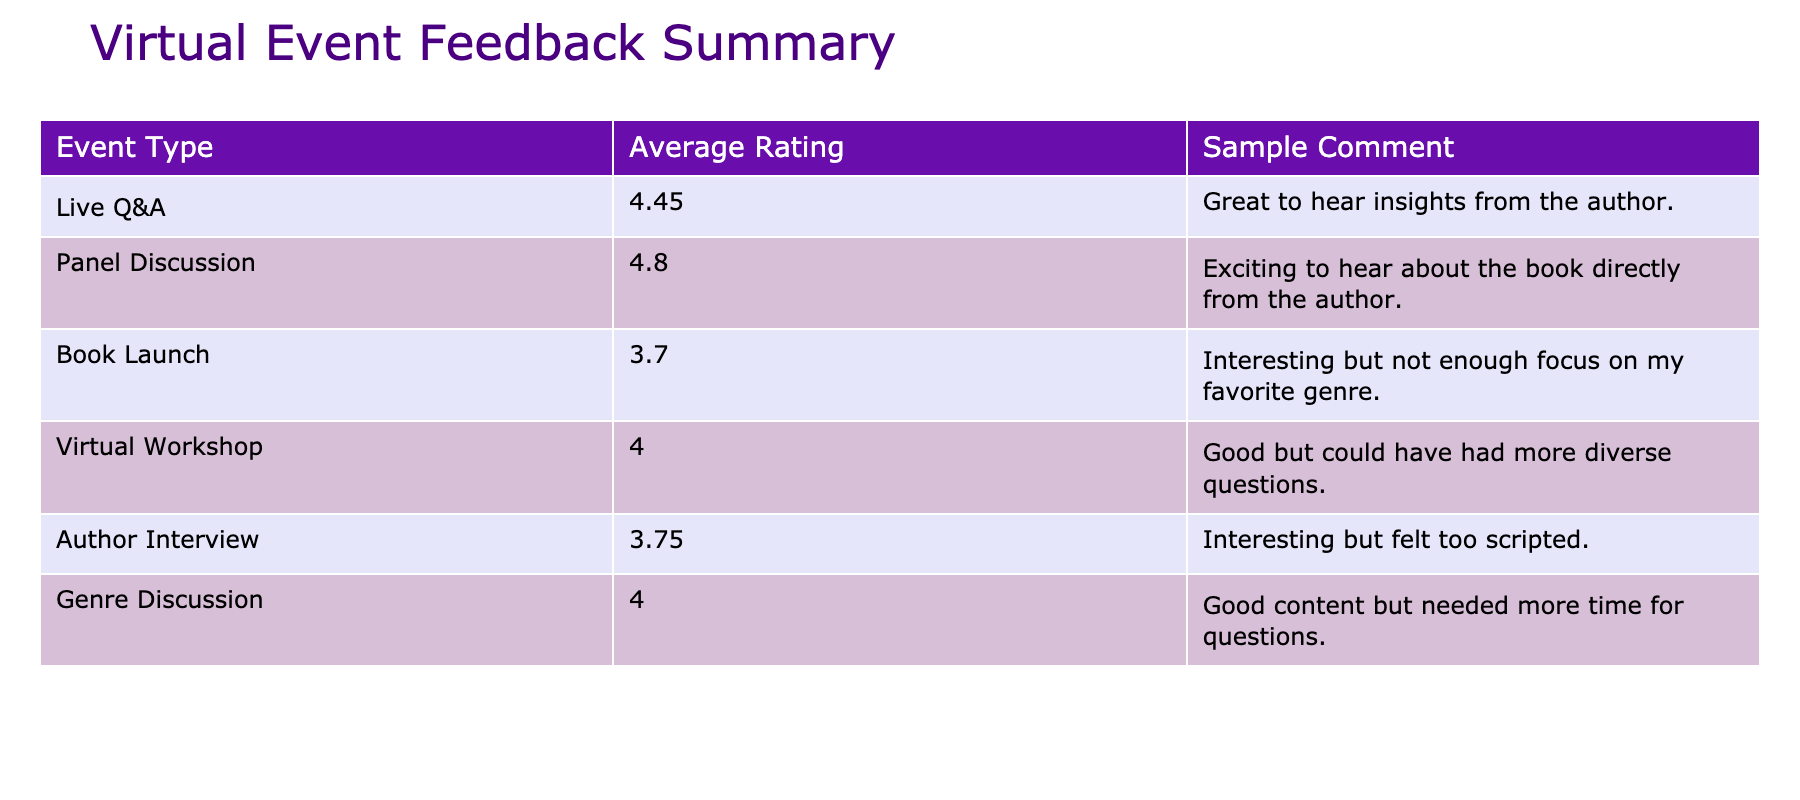What's the average feedback rating for the Author Interview event type? The Author Interview event has two feedback ratings (4.0 and 4.9). To find the average, we add them up: 4.0 + 4.9 = 8.9, then divide by 2, which equals 4.45.
Answer: 4.45 Which event type received the highest average rating? The average ratings are: Live Q&A (4.0), Panel Discussion (3.75), Book Launch (4.8), Virtual Workshop (4.0), Author Interview (4.45), and Genre Discussion (3.7). The highest is the Book Launch with 4.8.
Answer: Book Launch Is there any event type that has a feedback rating below 4.0? The Panel Discussion (3.75) and Genre Discussion (3.7) have ratings below 4.0, confirming that at least two event types fall below this threshold.
Answer: Yes What is the difference in average ratings between the highest and lowest event types? The highest average rating is 4.8 (Book Launch) and the lowest is 3.7 (Genre Discussion). The difference is 4.8 - 3.7 = 1.1.
Answer: 1.1 Did the Virtual Workshop receive mostly positive feedback? The average feedback rating for the Virtual Workshop is 4.0, which is considered a positive rating, confirming that it did receive positive feedback overall.
Answer: Yes What is the average feedback rating across all event types? The average ratings for all events are: Live Q&A (4.0), Panel Discussion (3.75), Book Launch (4.8), Virtual Workshop (4.0), Author Interview (4.45), and Genre Discussion (3.7). Adding these ratings gives us 4.0 + 3.75 + 4.8 + 4.0 + 4.45 + 3.7 = 24.0. Dividing by 6 (the number of event types), the average is 24.0 / 6 = 4.0.
Answer: 4.0 How many comments were included for the Panel Discussion event type? There are two participants who provided feedback for the Panel Discussion event type, indicating that only one comment was included for the average rating calculation since only the first is shown.
Answer: 1 Which event type had the most favorable comment based on the ratings given? The lowest score associated with a comment is 3.5 (Panel Discussion), while the highest is 4.9 (Author Interview), which is a very favorable comment about learning the writing process. Thus, the Author Interview had the most favorable comment based on the highest rating attributed to it.
Answer: Author Interview Which event format had a participant express a desire for more time for questions? The comment received for the Virtual Workshop indicates the participant thought the content was good but they needed more time for questions, referencing their experience directly.
Answer: Virtual Workshop What is the overall sentiment regarding the Book Launch event based on participant feedback? The Book Launch received the highest average rating of 4.8, along with a positive comment expressing excitement to hear directly from the author. Therefore, the overall sentiment is very positive.
Answer: Very positive 